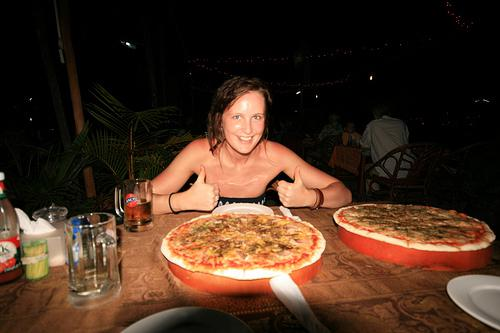Question: what gesture is the woman making?
Choices:
A. Peace sign.
B. Hand wave.
C. Thumbs-up.
D. Okay thumbs up.
Answer with the letter. Answer: C Question: what is the woman wearing?
Choices:
A. Shorts.
B. Dress.
C. Pants.
D. A tube top.
Answer with the letter. Answer: D Question: why is there pizza on the table?
Choices:
A. For lunch.
B. For dinner.
C. For the party.
D. For breakfast.
Answer with the letter. Answer: B Question: what is the woman wearing on her wrists?
Choices:
A. Watch.
B. Rubber band.
C. A tag.
D. Bracelets.
Answer with the letter. Answer: D 